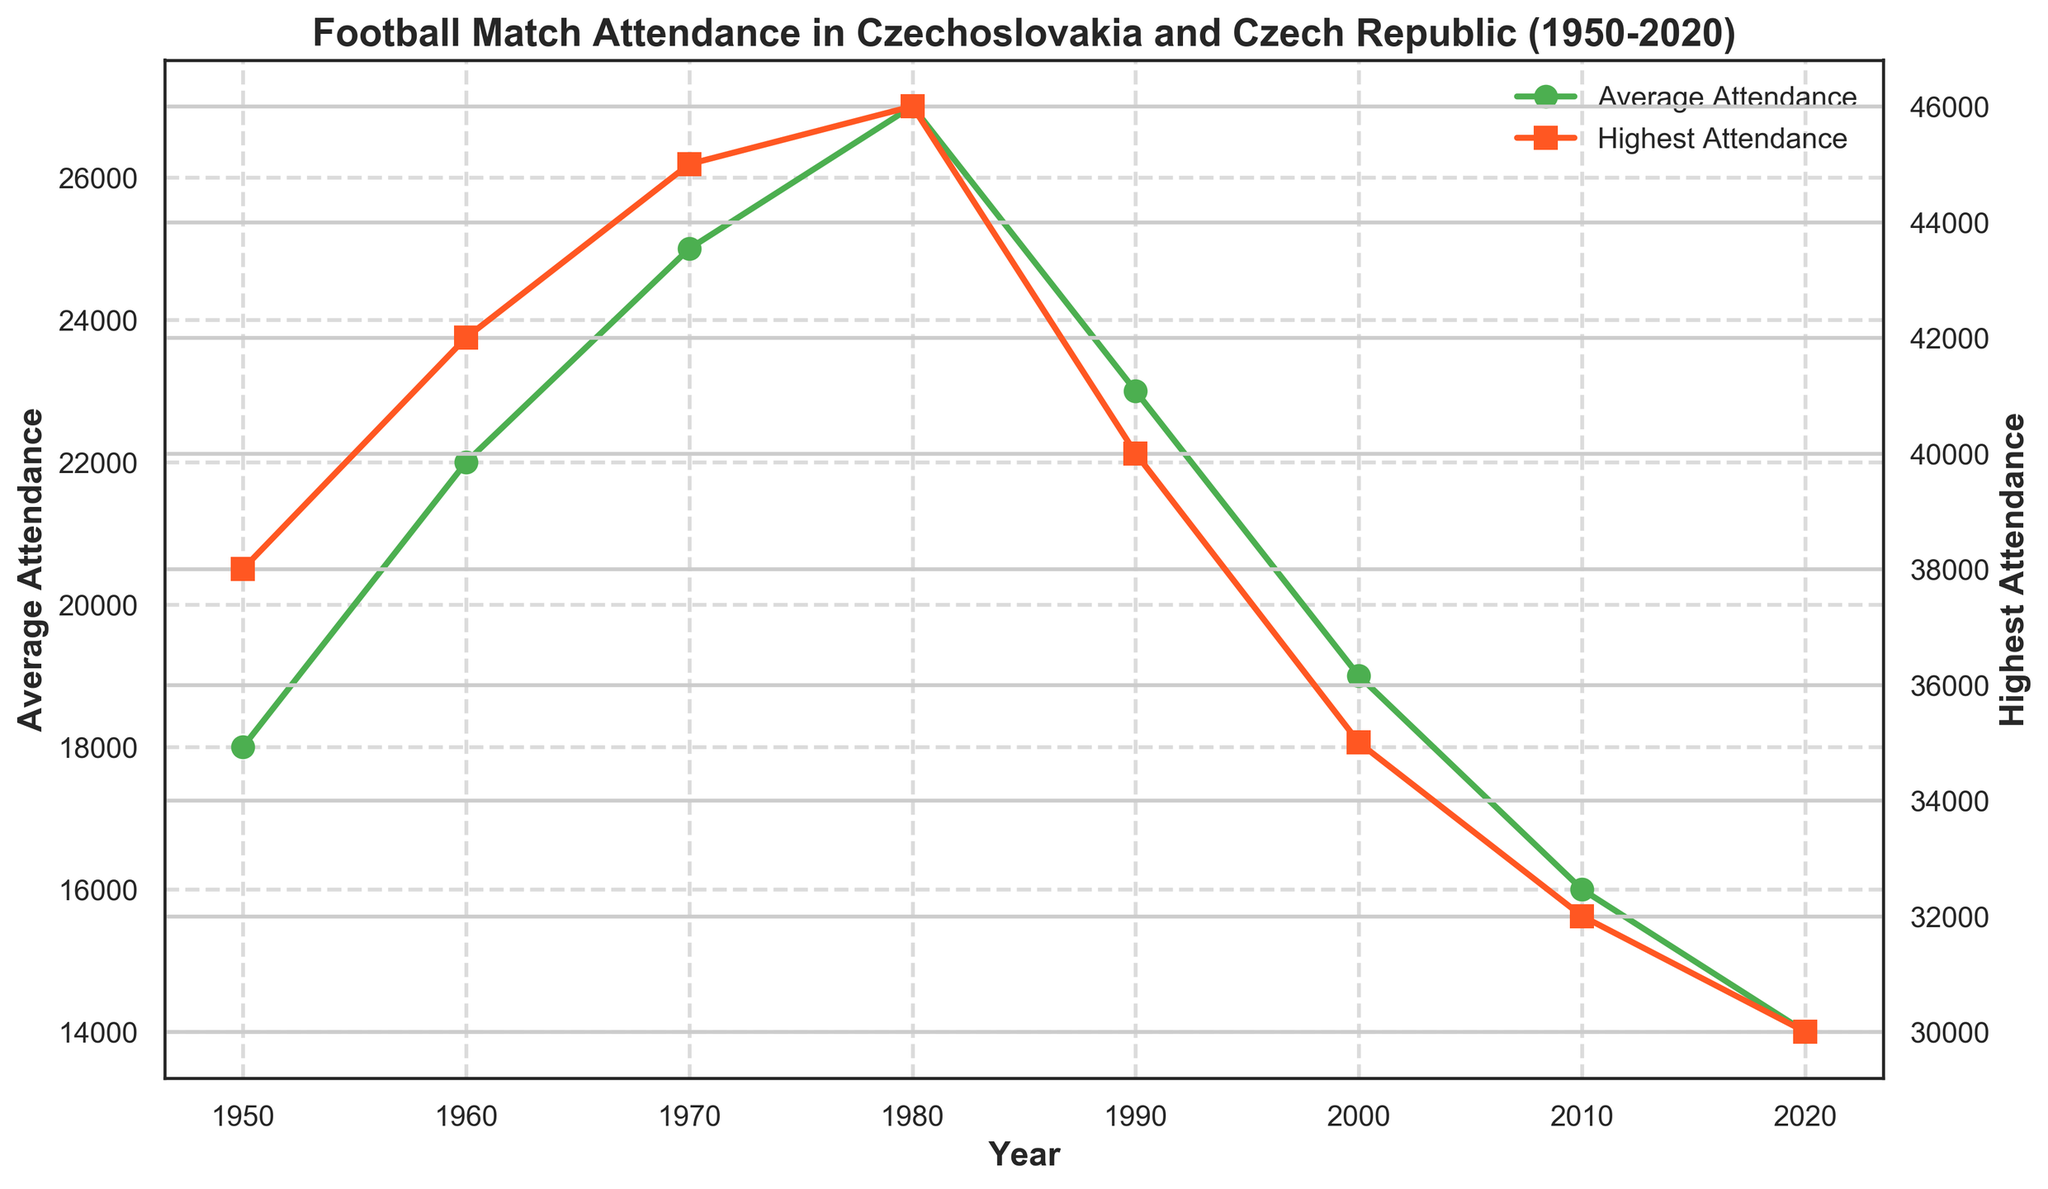When was the highest average attendance recorded? Scan the average attendance plot (green line) and look for the highest point, which is around 1980 as the data shows an average attendance of 27,000.
Answer: 1980 What is the trend of average attendance from 1950 to 2020? The green line shows a general downward trend from 1950 to 2020 with some fluctuations. The average attendance peaks in 1980 and then gradually decreases.
Answer: Downward trend How much did the average attendance decrease from 1980 to 2020? In 1980, the average attendance was 27,000. By 2020, it decreased to 14,000. Subtract the latter from the former: 27,000 - 14,000 = 13,000.
Answer: 13,000 Which match had the highest attendance and in what year was it? Look at the highest attendance plot (orange line) and find the peak, which is in 1980 for the match between Slavia Prague and Bohemians Prague at Eden Arena with 46,000 attendees.
Answer: Slavia Prague vs Bohemians Prague in 1980 Between which years did the average attendance decrease the most? Compare the gaps between plotted points on the average attendance line. The largest drop appears between 1980 (27,000) and 1990 (23,000): 27,000 - 23,000 = 4,000.
Answer: 1980 and 1990 What is the difference between the highest and average attendance in 1970? The highest attendance in 1970 was 45,000 and the average attendance was 25,000. Subtract the average from the highest: 45,000 - 25,000 = 20,000.
Answer: 20,000 How does the highest attendance in 2000 compare to that in 1960? The highest attendance in 2000 is 35,000 and in 1960 it is 42,000. So, 35,000 is less than 42,000.
Answer: Less than What is the general relationship between average and highest attendance over the years? The highest attendance (orange line) is consistently higher than the average attendance (green line) throughout all the years. Both lines show a general declining trend from 1980 onwards.
Answer: Highest attendance is consistently higher How many years show both average and highest attendance values above 25,000? Count the years where both lines exceed 25,000. Both lines exceed 25,000 in 1960, 1970, and 1980, which totals to three years.
Answer: 3 years 